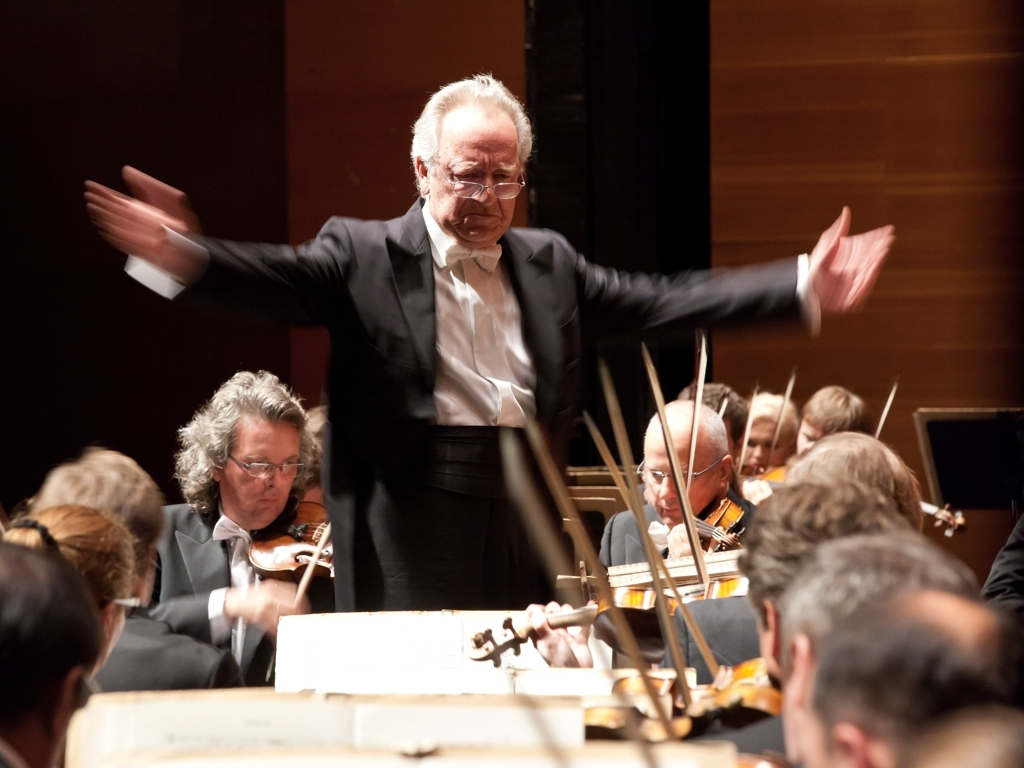What is the mood conveyed by the conductor's expression and gestures? The conductor's intense expression and wide gesturing connote a deep immersion in the music, possibly indicating a climactic or powerful segment of the performance. His passionate demeanor suggests he's leading the orchestra with vigor, aiming to evoke a strong emotional response from both the musicians and the audience. 